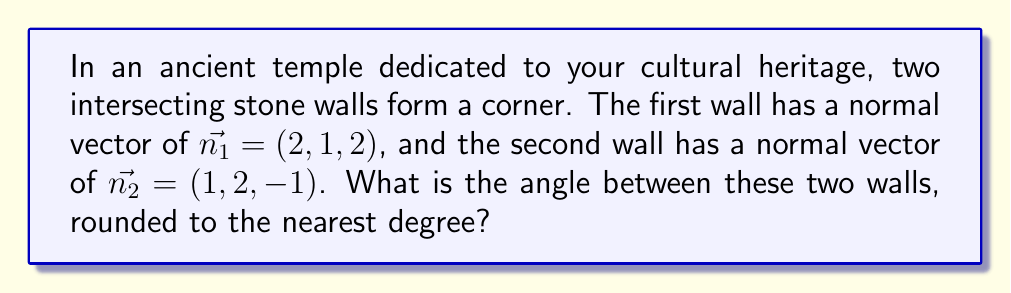Can you answer this question? To find the angle between two intersecting planes, we can use the dot product of their normal vectors. The formula for the angle $\theta$ between two planes with normal vectors $\vec{n_1}$ and $\vec{n_2}$ is:

$$\cos \theta = \frac{\vec{n_1} \cdot \vec{n_2}}{|\vec{n_1}| |\vec{n_2}|}$$

Step 1: Calculate the dot product $\vec{n_1} \cdot \vec{n_2}$
$$\vec{n_1} \cdot \vec{n_2} = (2)(1) + (1)(2) + (2)(-1) = 2 + 2 - 2 = 2$$

Step 2: Calculate the magnitudes of the normal vectors
$$|\vec{n_1}| = \sqrt{2^2 + 1^2 + 2^2} = \sqrt{9} = 3$$
$$|\vec{n_2}| = \sqrt{1^2 + 2^2 + (-1)^2} = \sqrt{6}$$

Step 3: Apply the formula
$$\cos \theta = \frac{2}{3\sqrt{6}}$$

Step 4: Take the inverse cosine (arccos) of both sides
$$\theta = \arccos\left(\frac{2}{3\sqrt{6}}\right)$$

Step 5: Calculate and round to the nearest degree
$$\theta \approx 73.22^\circ \approx 73^\circ$$
Answer: $73^\circ$ 